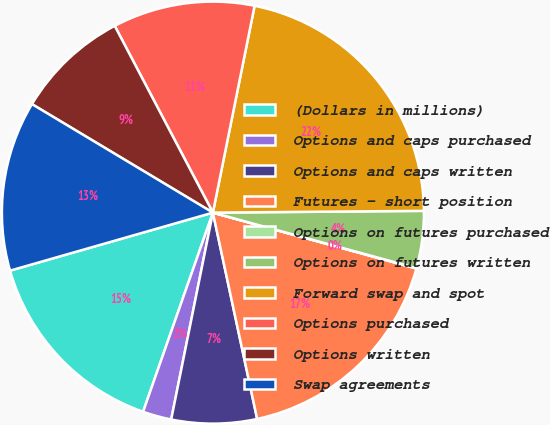Convert chart. <chart><loc_0><loc_0><loc_500><loc_500><pie_chart><fcel>(Dollars in millions)<fcel>Options and caps purchased<fcel>Options and caps written<fcel>Futures - short position<fcel>Options on futures purchased<fcel>Options on futures written<fcel>Forward swap and spot<fcel>Options purchased<fcel>Options written<fcel>Swap agreements<nl><fcel>15.2%<fcel>2.2%<fcel>6.53%<fcel>17.37%<fcel>0.03%<fcel>4.37%<fcel>21.7%<fcel>10.87%<fcel>8.7%<fcel>13.03%<nl></chart> 